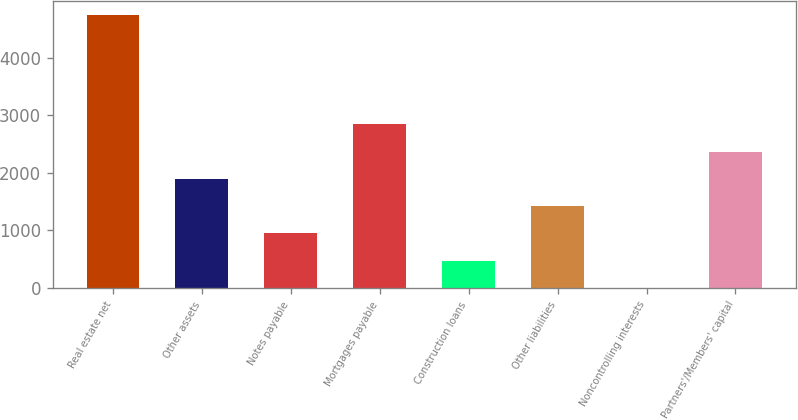Convert chart. <chart><loc_0><loc_0><loc_500><loc_500><bar_chart><fcel>Real estate net<fcel>Other assets<fcel>Notes payable<fcel>Mortgages payable<fcel>Construction loans<fcel>Other liabilities<fcel>Noncontrolling interests<fcel>Partners'/Members' capital<nl><fcel>4739.5<fcel>1896.4<fcel>948.7<fcel>2844.1<fcel>474.85<fcel>1422.55<fcel>1<fcel>2370.25<nl></chart> 